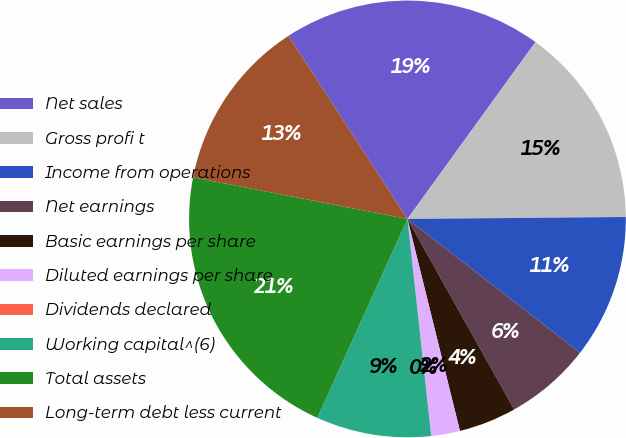<chart> <loc_0><loc_0><loc_500><loc_500><pie_chart><fcel>Net sales<fcel>Gross profi t<fcel>Income from operations<fcel>Net earnings<fcel>Basic earnings per share<fcel>Diluted earnings per share<fcel>Dividends declared<fcel>Working capital^(6)<fcel>Total assets<fcel>Long-term debt less current<nl><fcel>19.15%<fcel>14.89%<fcel>10.64%<fcel>6.38%<fcel>4.26%<fcel>2.13%<fcel>0.0%<fcel>8.51%<fcel>21.28%<fcel>12.77%<nl></chart> 